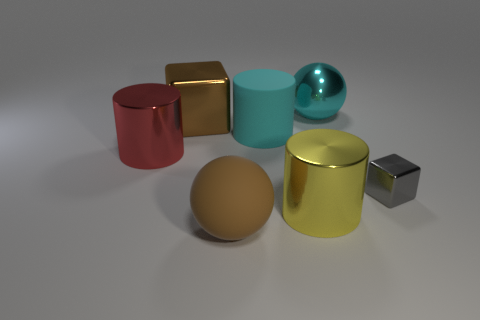Subtract all purple spheres. Subtract all purple blocks. How many spheres are left? 2 Subtract all purple spheres. How many blue cylinders are left? 0 Add 2 big yellows. How many small objects exist? 0 Subtract all large gray metallic spheres. Subtract all red cylinders. How many objects are left? 6 Add 3 large red objects. How many large red objects are left? 4 Add 1 tiny blue matte balls. How many tiny blue matte balls exist? 1 Add 1 cyan matte things. How many objects exist? 8 Subtract all gray blocks. How many blocks are left? 1 Subtract all big shiny cylinders. How many cylinders are left? 1 Subtract 0 blue blocks. How many objects are left? 7 